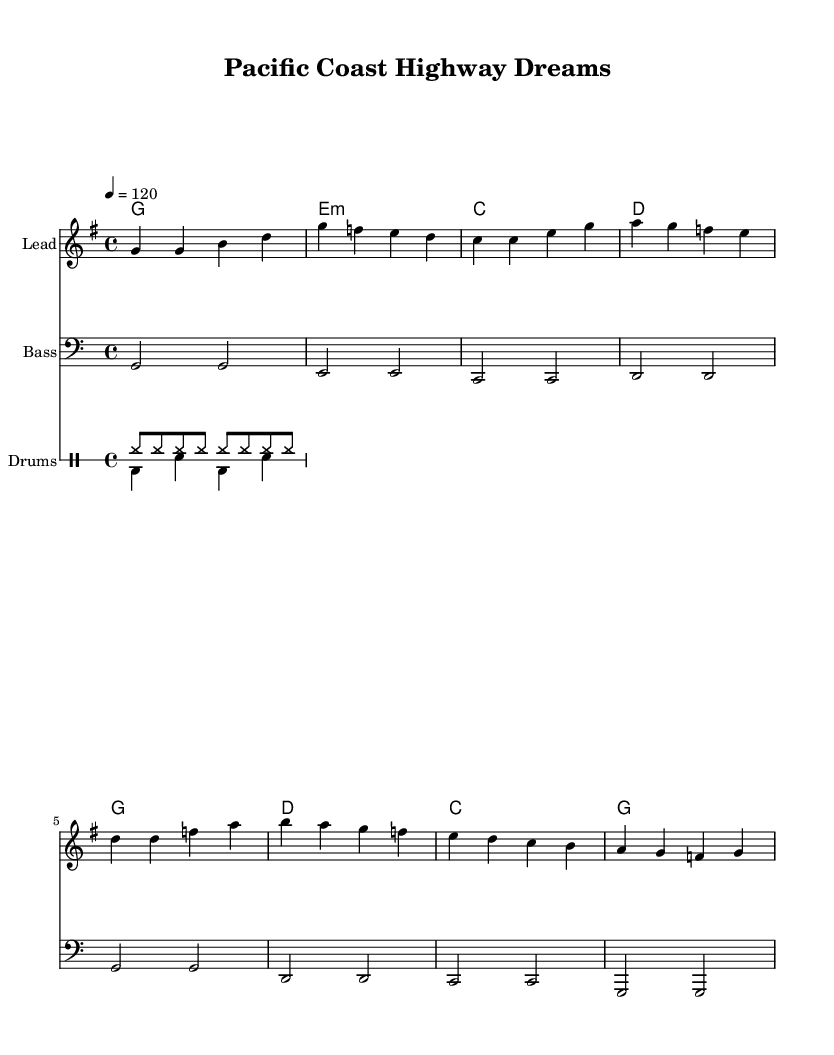What is the key signature of this music? The key signature is indicated at the beginning of the staff, showing one sharp, which corresponds to the G major scale.
Answer: G major What is the time signature of this piece? The time signature is located at the start of the music, showing a “4/4” signature, meaning there are four beats in a measure and the quarter note gets one beat.
Answer: 4/4 What is the tempo marking for this piece? The tempo marking is indicated at the top of the music, stating "4 = 120," which means to play at a pace of 120 beats per minute.
Answer: 120 What is the name of this composition? The title is displayed at the top of the sheet music under the header section, listing the piece as "Pacific Coast Highway Dreams."
Answer: Pacific Coast Highway Dreams What instruments are featured in this sheet music? The instruments can be found in the header section and in the staff names: a lead instrument, bass, and drums are all present.
Answer: Lead, Bass, Drums How many measures are there in the melody section? Counting the measures in the melody part shows a total of 8 measures, each separated by a bar line.
Answer: 8 measures What musical form do the chords present imply in this piece? By analyzing the chord progression, it suggests a typical verse-chorus structure, often seen in classic rock anthems, commonly alternating between the chorus and verse chords.
Answer: Verse-Chorus Structure 